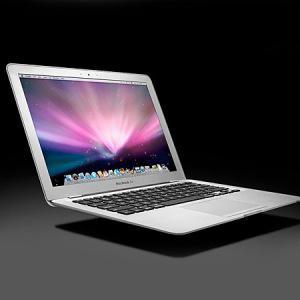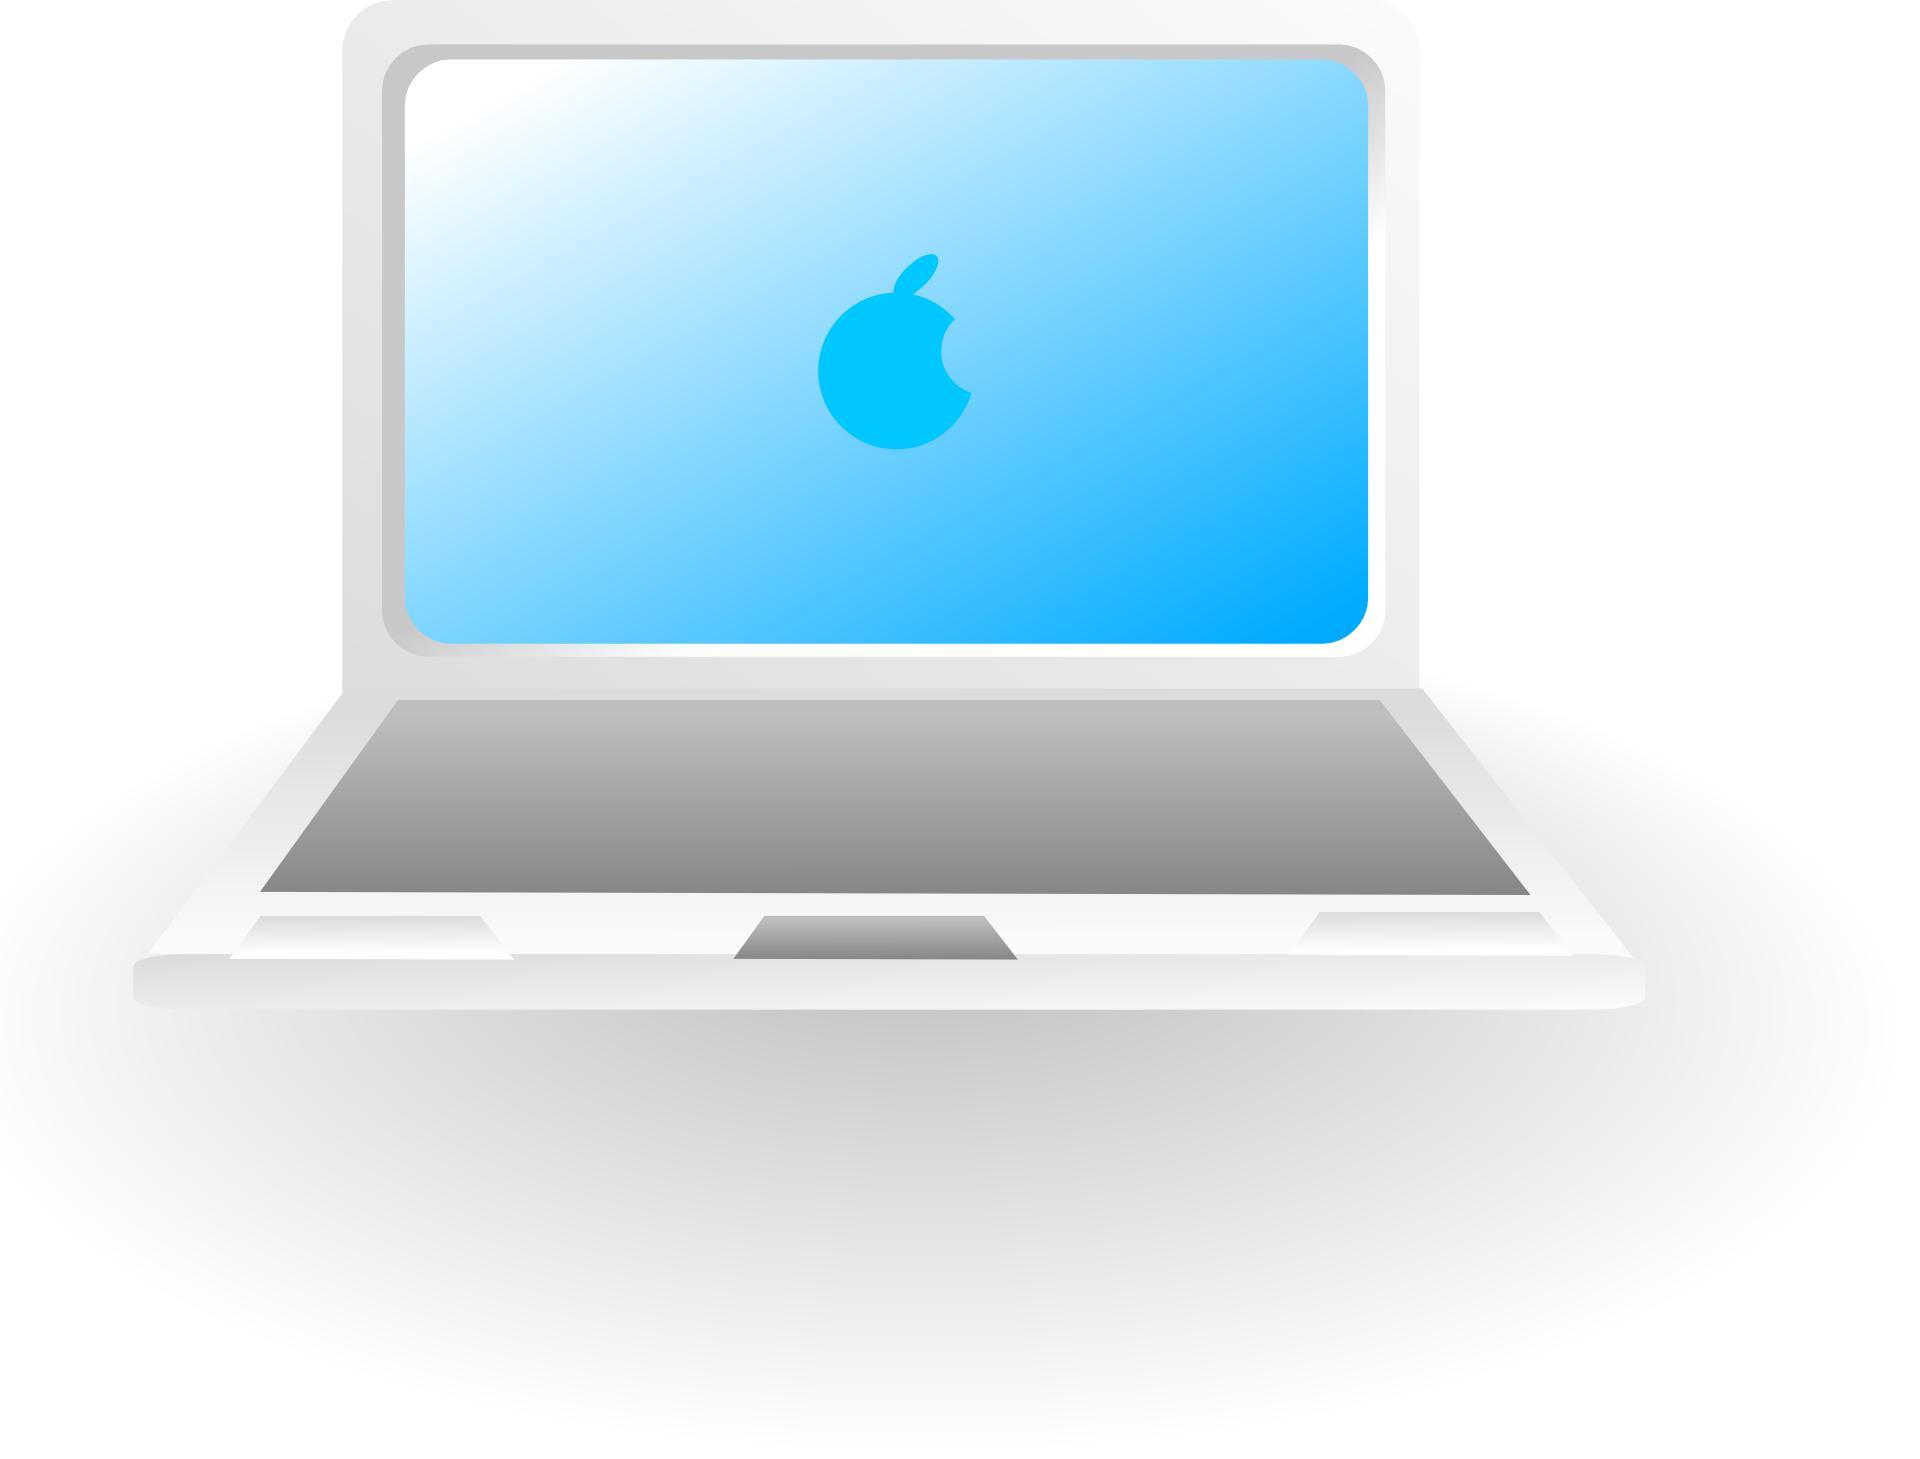The first image is the image on the left, the second image is the image on the right. For the images shown, is this caption "The logo on the back of the laptop is clearly visible in at least one image." true? Answer yes or no. No. The first image is the image on the left, the second image is the image on the right. Assess this claim about the two images: "In at least one of the photos, the screen is seen bent in at a sharp angle.". Correct or not? Answer yes or no. No. 